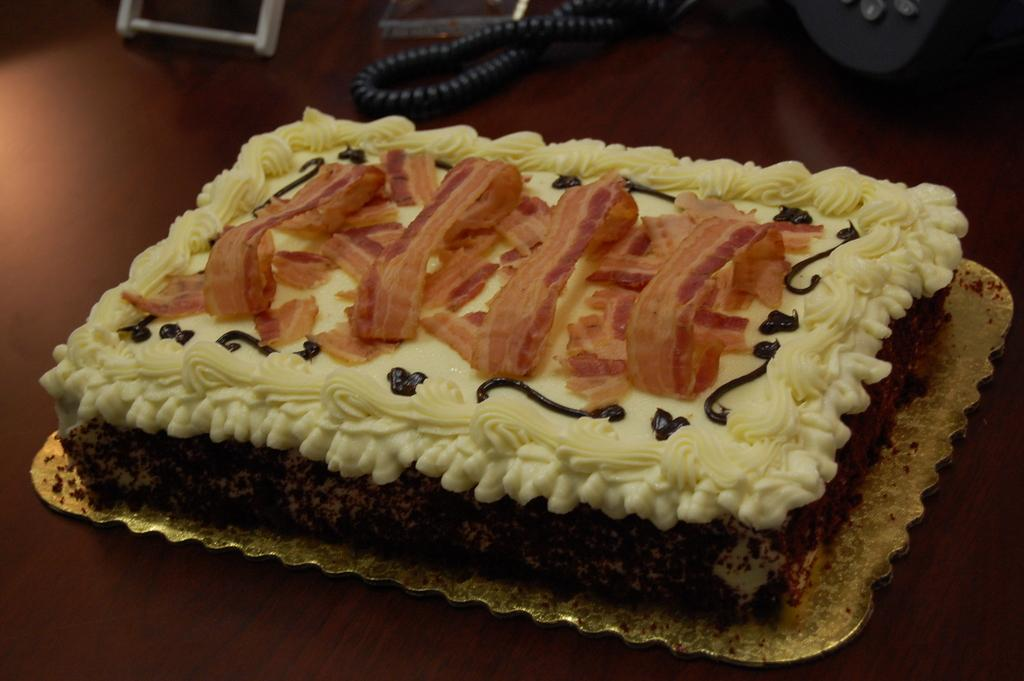What is the main subject of the image? There is a cake in the image. Where is the cake located? The cake is on a platform. What can be seen in the background of the image? There is a spring visible in the background of the image. What type of spy equipment can be seen in the image? There is no spy equipment present in the image; it features a cake on a platform with a spring visible in the background. Are there any pets visible in the image? There are no pets present in the image. 